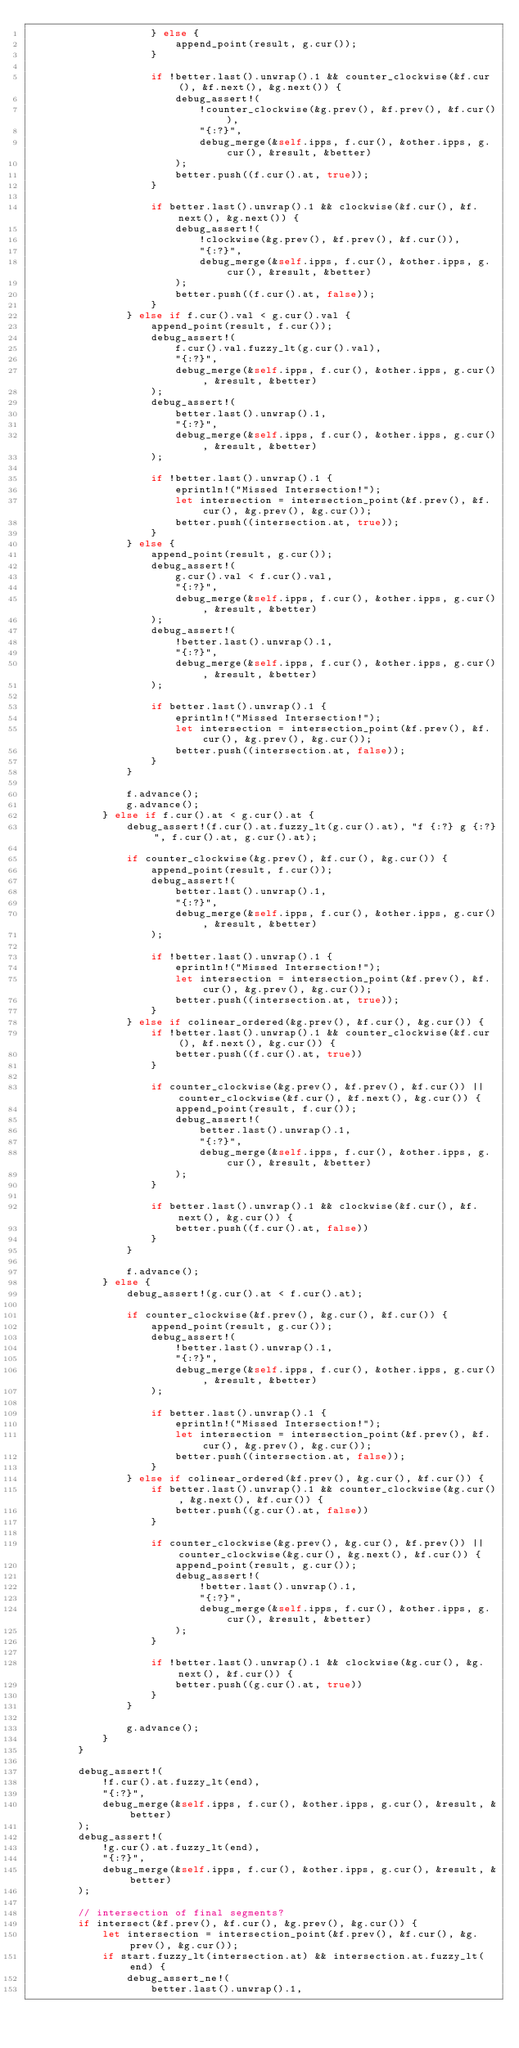Convert code to text. <code><loc_0><loc_0><loc_500><loc_500><_Rust_>                    } else {
                        append_point(result, g.cur());
                    }

                    if !better.last().unwrap().1 && counter_clockwise(&f.cur(), &f.next(), &g.next()) {
                        debug_assert!(
                            !counter_clockwise(&g.prev(), &f.prev(), &f.cur()),
                            "{:?}",
                            debug_merge(&self.ipps, f.cur(), &other.ipps, g.cur(), &result, &better)
                        );
                        better.push((f.cur().at, true));
                    }

                    if better.last().unwrap().1 && clockwise(&f.cur(), &f.next(), &g.next()) {
                        debug_assert!(
                            !clockwise(&g.prev(), &f.prev(), &f.cur()),
                            "{:?}",
                            debug_merge(&self.ipps, f.cur(), &other.ipps, g.cur(), &result, &better)
                        );
                        better.push((f.cur().at, false));
                    }
                } else if f.cur().val < g.cur().val {
                    append_point(result, f.cur());
                    debug_assert!(
                        f.cur().val.fuzzy_lt(g.cur().val),
                        "{:?}",
                        debug_merge(&self.ipps, f.cur(), &other.ipps, g.cur(), &result, &better)
                    );
                    debug_assert!(
                        better.last().unwrap().1,
                        "{:?}",
                        debug_merge(&self.ipps, f.cur(), &other.ipps, g.cur(), &result, &better)
                    );

                    if !better.last().unwrap().1 {
                        eprintln!("Missed Intersection!");
                        let intersection = intersection_point(&f.prev(), &f.cur(), &g.prev(), &g.cur());
                        better.push((intersection.at, true));
                    }
                } else {
                    append_point(result, g.cur());
                    debug_assert!(
                        g.cur().val < f.cur().val,
                        "{:?}",
                        debug_merge(&self.ipps, f.cur(), &other.ipps, g.cur(), &result, &better)
                    );
                    debug_assert!(
                        !better.last().unwrap().1,
                        "{:?}",
                        debug_merge(&self.ipps, f.cur(), &other.ipps, g.cur(), &result, &better)
                    );

                    if better.last().unwrap().1 {
                        eprintln!("Missed Intersection!");
                        let intersection = intersection_point(&f.prev(), &f.cur(), &g.prev(), &g.cur());
                        better.push((intersection.at, false));
                    }
                }

                f.advance();
                g.advance();
            } else if f.cur().at < g.cur().at {
                debug_assert!(f.cur().at.fuzzy_lt(g.cur().at), "f {:?} g {:?}", f.cur().at, g.cur().at);

                if counter_clockwise(&g.prev(), &f.cur(), &g.cur()) {
                    append_point(result, f.cur());
                    debug_assert!(
                        better.last().unwrap().1,
                        "{:?}",
                        debug_merge(&self.ipps, f.cur(), &other.ipps, g.cur(), &result, &better)
                    );

                    if !better.last().unwrap().1 {
                        eprintln!("Missed Intersection!");
                        let intersection = intersection_point(&f.prev(), &f.cur(), &g.prev(), &g.cur());
                        better.push((intersection.at, true));
                    }
                } else if colinear_ordered(&g.prev(), &f.cur(), &g.cur()) {
                    if !better.last().unwrap().1 && counter_clockwise(&f.cur(), &f.next(), &g.cur()) {
                        better.push((f.cur().at, true))
                    }

                    if counter_clockwise(&g.prev(), &f.prev(), &f.cur()) || counter_clockwise(&f.cur(), &f.next(), &g.cur()) {
                        append_point(result, f.cur());
                        debug_assert!(
                            better.last().unwrap().1,
                            "{:?}",
                            debug_merge(&self.ipps, f.cur(), &other.ipps, g.cur(), &result, &better)
                        );
                    }

                    if better.last().unwrap().1 && clockwise(&f.cur(), &f.next(), &g.cur()) {
                        better.push((f.cur().at, false))
                    }
                }

                f.advance();
            } else {
                debug_assert!(g.cur().at < f.cur().at);

                if counter_clockwise(&f.prev(), &g.cur(), &f.cur()) {
                    append_point(result, g.cur());
                    debug_assert!(
                        !better.last().unwrap().1,
                        "{:?}",
                        debug_merge(&self.ipps, f.cur(), &other.ipps, g.cur(), &result, &better)
                    );

                    if better.last().unwrap().1 {
                        eprintln!("Missed Intersection!");
                        let intersection = intersection_point(&f.prev(), &f.cur(), &g.prev(), &g.cur());
                        better.push((intersection.at, false));
                    }
                } else if colinear_ordered(&f.prev(), &g.cur(), &f.cur()) {
                    if better.last().unwrap().1 && counter_clockwise(&g.cur(), &g.next(), &f.cur()) {
                        better.push((g.cur().at, false))
                    }

                    if counter_clockwise(&g.prev(), &g.cur(), &f.prev()) || counter_clockwise(&g.cur(), &g.next(), &f.cur()) {
                        append_point(result, g.cur());
                        debug_assert!(
                            !better.last().unwrap().1,
                            "{:?}",
                            debug_merge(&self.ipps, f.cur(), &other.ipps, g.cur(), &result, &better)
                        );
                    }

                    if !better.last().unwrap().1 && clockwise(&g.cur(), &g.next(), &f.cur()) {
                        better.push((g.cur().at, true))
                    }
                }

                g.advance();
            }
        }

        debug_assert!(
            !f.cur().at.fuzzy_lt(end),
            "{:?}",
            debug_merge(&self.ipps, f.cur(), &other.ipps, g.cur(), &result, &better)
        );
        debug_assert!(
            !g.cur().at.fuzzy_lt(end),
            "{:?}",
            debug_merge(&self.ipps, f.cur(), &other.ipps, g.cur(), &result, &better)
        );

        // intersection of final segments?
        if intersect(&f.prev(), &f.cur(), &g.prev(), &g.cur()) {
            let intersection = intersection_point(&f.prev(), &f.cur(), &g.prev(), &g.cur());
            if start.fuzzy_lt(intersection.at) && intersection.at.fuzzy_lt(end) {
                debug_assert_ne!(
                    better.last().unwrap().1,</code> 